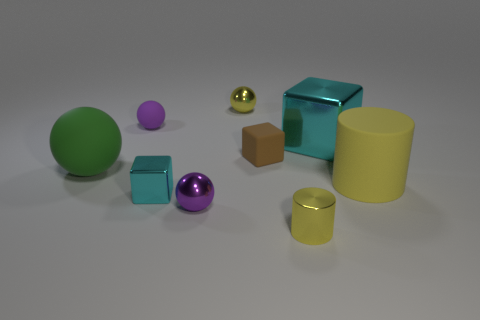Subtract all balls. How many objects are left? 5 Subtract 1 cylinders. How many cylinders are left? 1 Subtract all cyan cubes. How many cubes are left? 1 Subtract all big shiny blocks. How many blocks are left? 2 Subtract 1 green spheres. How many objects are left? 8 Subtract all cyan cylinders. Subtract all yellow cubes. How many cylinders are left? 2 Subtract all green spheres. How many cyan blocks are left? 2 Subtract all blue balls. Subtract all purple matte spheres. How many objects are left? 8 Add 5 large rubber cylinders. How many large rubber cylinders are left? 6 Add 2 green things. How many green things exist? 3 